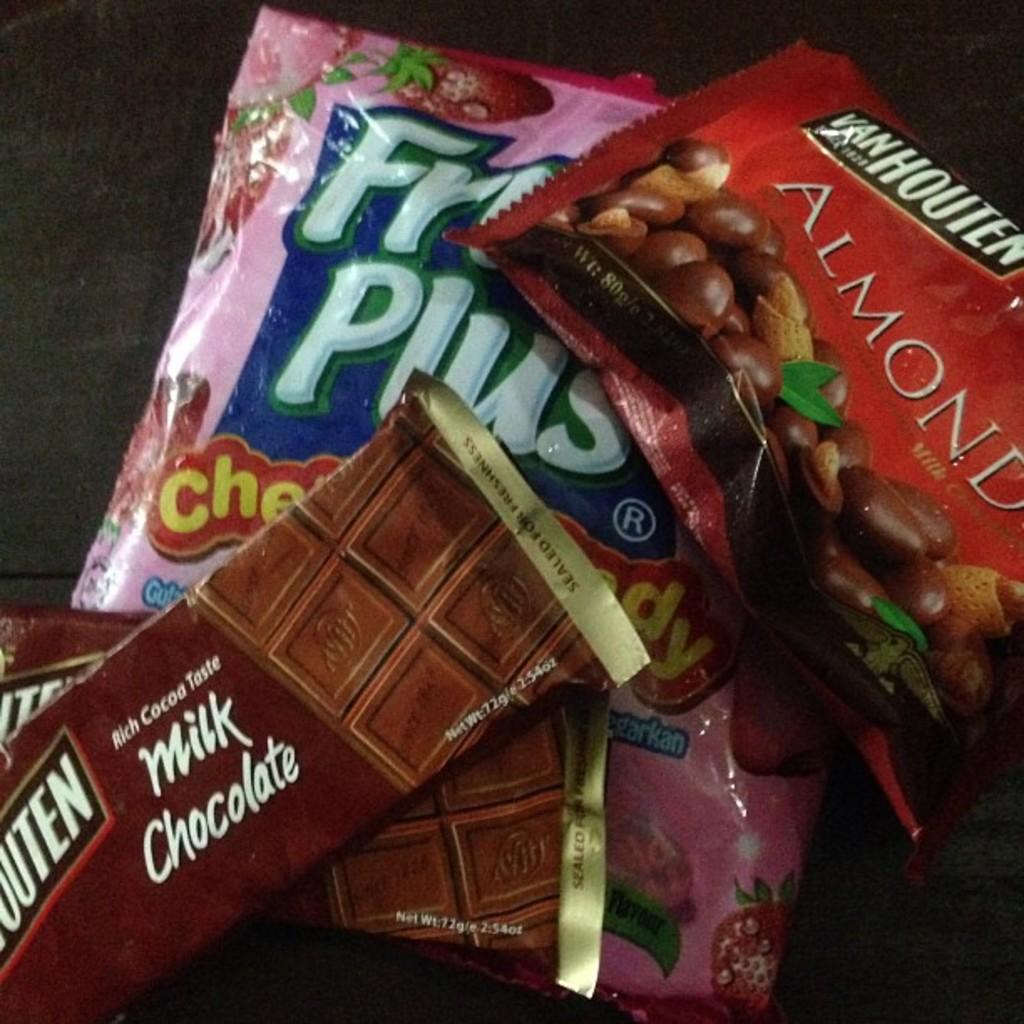What type of chocolates are visible in the image? There are chocolates in the image, but the specific type cannot be determined from the facts provided. Where are the chocolates located in the image? The chocolates are kept on the floor in the image. How many years has the twig been in jail in the image? There is no twig or jail present in the image, so this question cannot be answered. 